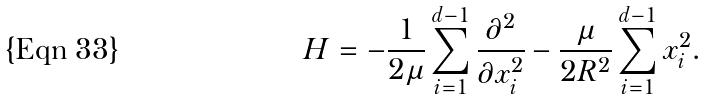<formula> <loc_0><loc_0><loc_500><loc_500>H = - \frac { 1 } { 2 \mu } \sum _ { i = 1 } ^ { d - 1 } \frac { \partial ^ { 2 } } { \partial x ^ { 2 } _ { i } } - \frac { \mu } { 2 R ^ { 2 } } \sum _ { i = 1 } ^ { d - 1 } x ^ { 2 } _ { i } .</formula> 